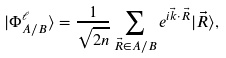Convert formula to latex. <formula><loc_0><loc_0><loc_500><loc_500>| \Phi _ { A / B } ^ { \ell } \rangle = \frac { 1 } { \sqrt { 2 n } } \sum _ { \vec { R } \in A / B } e ^ { i \vec { k } \cdot \vec { R } } | \vec { R } \rangle ,</formula> 